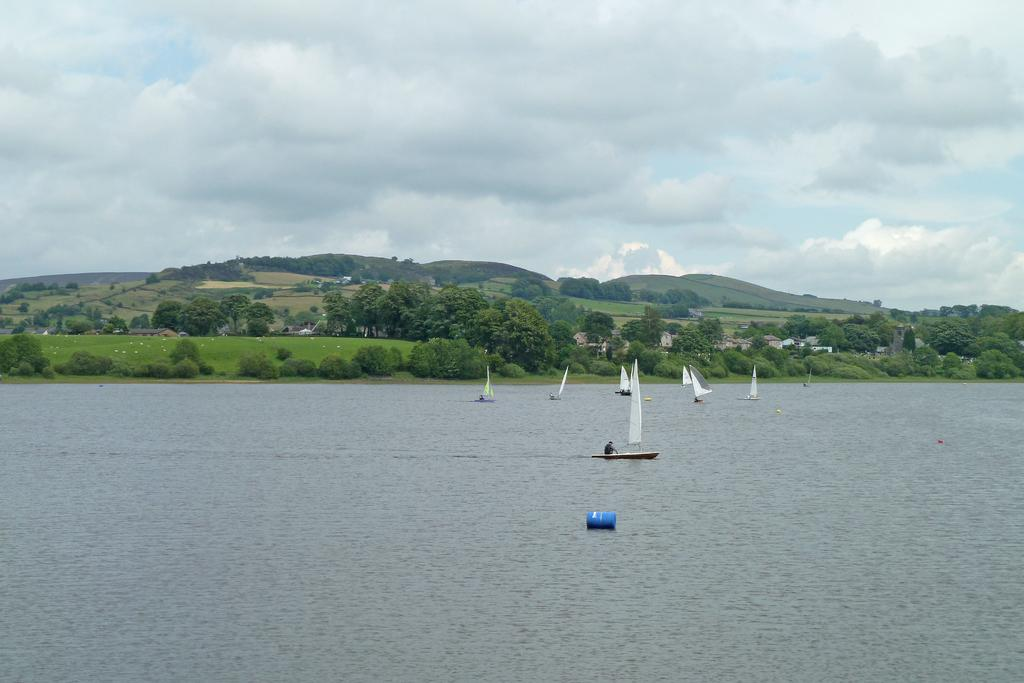What is the main element in the image? There is water in the image. What is on the water? There are boats on the water. What can be seen in the background of the image? There are trees, hills, sheds, and the sky visible in the background of the image. What type of scarf is being used as a pancake topping in the image? There is no scarf or pancake present in the image. What word is being spelled out by the boats in the image? The boats in the image are not spelling out any words; they are simply floating on the water. 